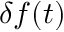<formula> <loc_0><loc_0><loc_500><loc_500>\delta f ( t )</formula> 